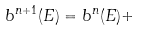Convert formula to latex. <formula><loc_0><loc_0><loc_500><loc_500>b ^ { n + 1 } ( E ) = b ^ { n } ( E ) +</formula> 